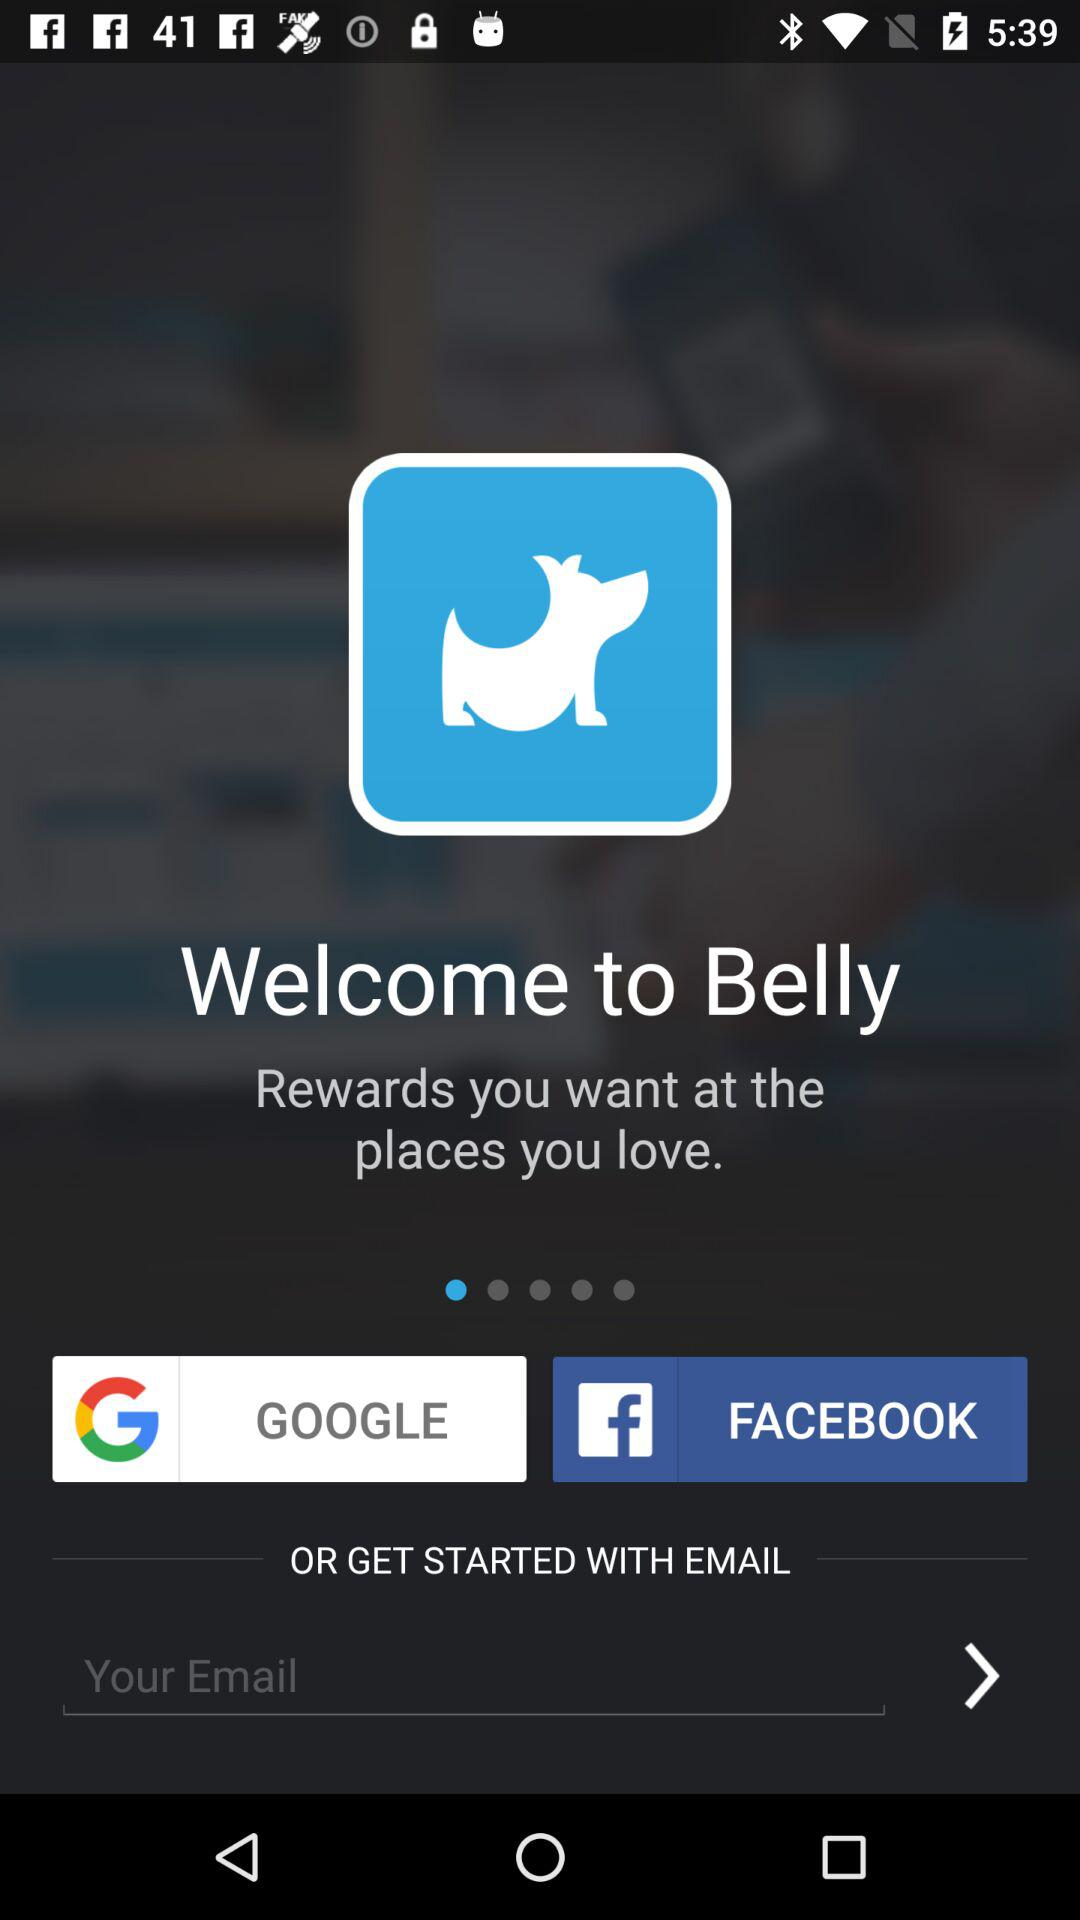What is the application name? The application name is "Belly". 